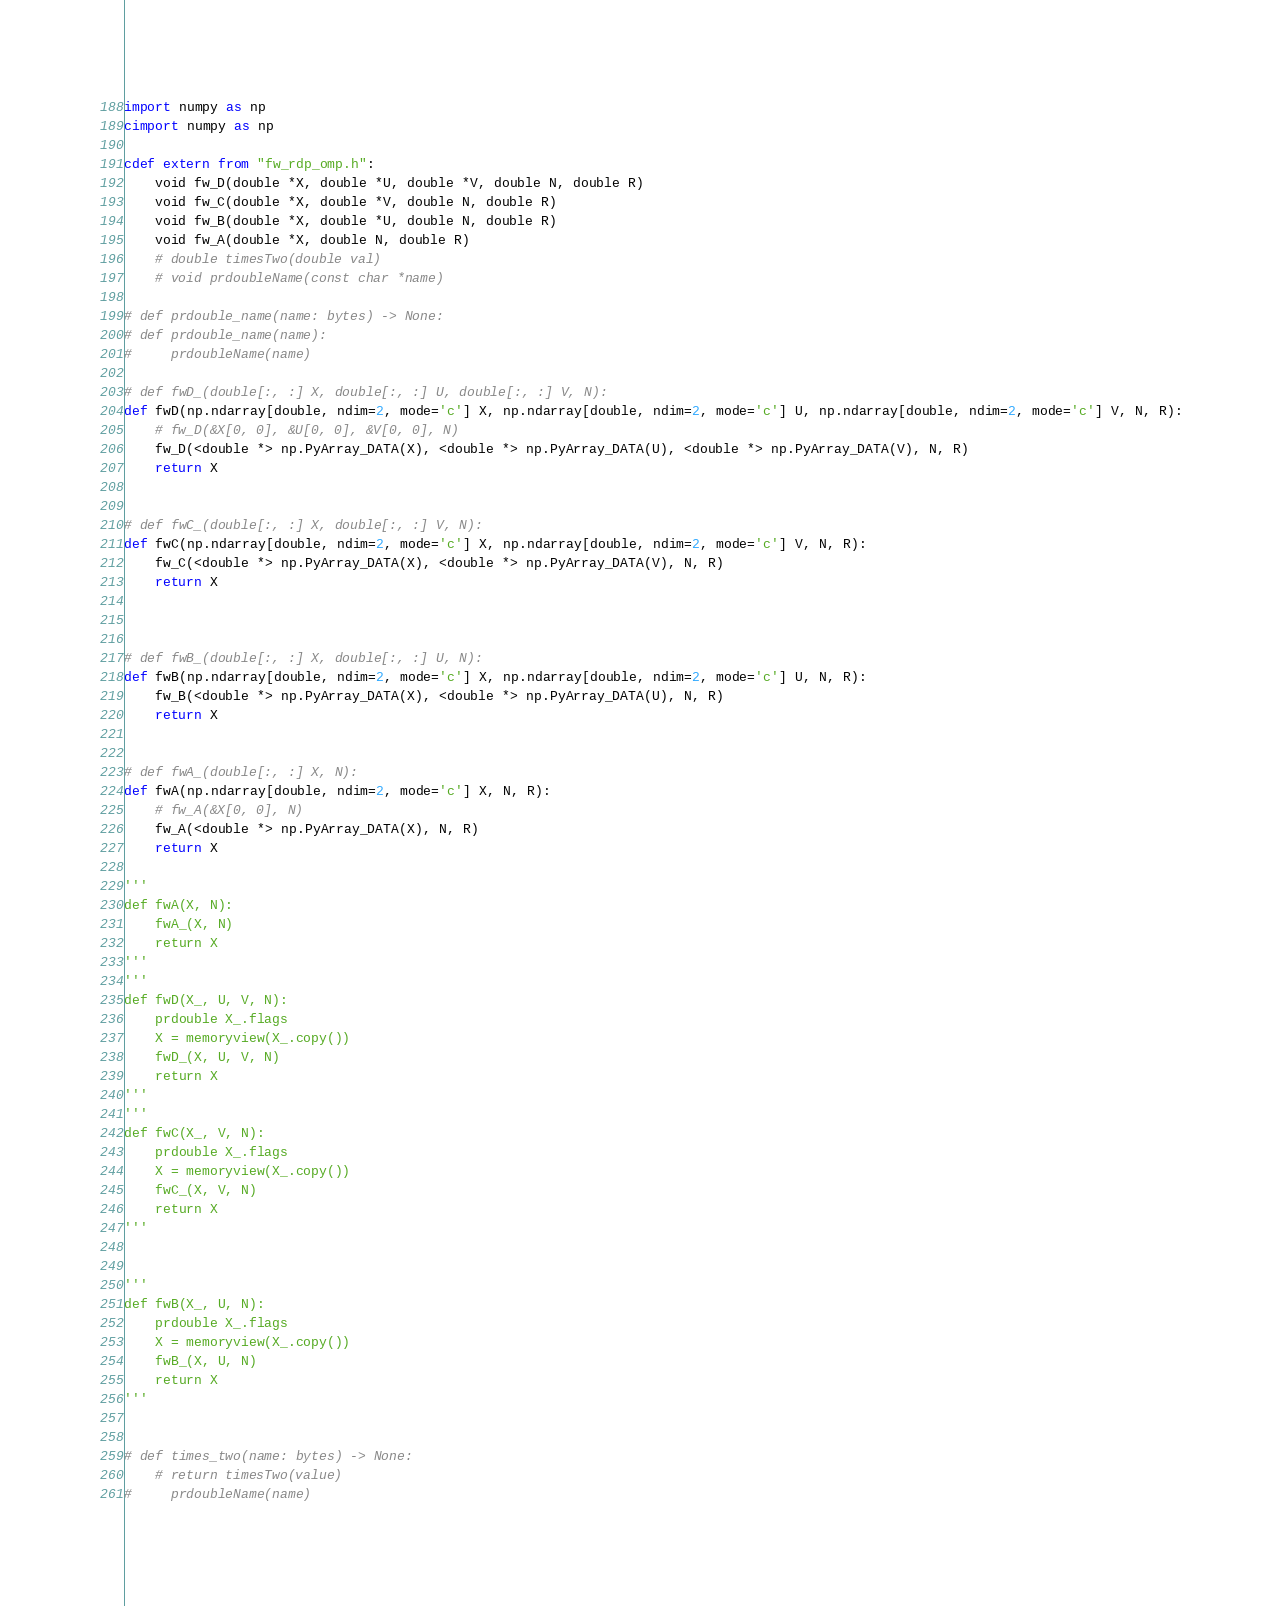Convert code to text. <code><loc_0><loc_0><loc_500><loc_500><_Cython_>import numpy as np
cimport numpy as np

cdef extern from "fw_rdp_omp.h":
    void fw_D(double *X, double *U, double *V, double N, double R)
    void fw_C(double *X, double *V, double N, double R)
    void fw_B(double *X, double *U, double N, double R) 
    void fw_A(double *X, double N, double R)
    # double timesTwo(double val)
    # void prdoubleName(const char *name)

# def prdouble_name(name: bytes) -> None:
# def prdouble_name(name):
#     prdoubleName(name)

# def fwD_(double[:, :] X, double[:, :] U, double[:, :] V, N):
def fwD(np.ndarray[double, ndim=2, mode='c'] X, np.ndarray[double, ndim=2, mode='c'] U, np.ndarray[double, ndim=2, mode='c'] V, N, R):
    # fw_D(&X[0, 0], &U[0, 0], &V[0, 0], N)
    fw_D(<double *> np.PyArray_DATA(X), <double *> np.PyArray_DATA(U), <double *> np.PyArray_DATA(V), N, R)
    return X


# def fwC_(double[:, :] X, double[:, :] V, N):
def fwC(np.ndarray[double, ndim=2, mode='c'] X, np.ndarray[double, ndim=2, mode='c'] V, N, R):
    fw_C(<double *> np.PyArray_DATA(X), <double *> np.PyArray_DATA(V), N, R)
    return X



# def fwB_(double[:, :] X, double[:, :] U, N):
def fwB(np.ndarray[double, ndim=2, mode='c'] X, np.ndarray[double, ndim=2, mode='c'] U, N, R):
    fw_B(<double *> np.PyArray_DATA(X), <double *> np.PyArray_DATA(U), N, R)
    return X


# def fwA_(double[:, :] X, N):
def fwA(np.ndarray[double, ndim=2, mode='c'] X, N, R):
    # fw_A(&X[0, 0], N)
    fw_A(<double *> np.PyArray_DATA(X), N, R)
    return X

'''
def fwA(X, N):
    fwA_(X, N)
    return X
'''
'''
def fwD(X_, U, V, N):
    prdouble X_.flags
    X = memoryview(X_.copy())
    fwD_(X, U, V, N)
    return X
'''
'''
def fwC(X_, V, N):
    prdouble X_.flags
    X = memoryview(X_.copy())
    fwC_(X, V, N)
    return X
'''


'''
def fwB(X_, U, N):
    prdouble X_.flags
    X = memoryview(X_.copy())
    fwB_(X, U, N)
    return X
'''


# def times_two(name: bytes) -> None:
    # return timesTwo(value)
#     prdoubleName(name)
</code> 